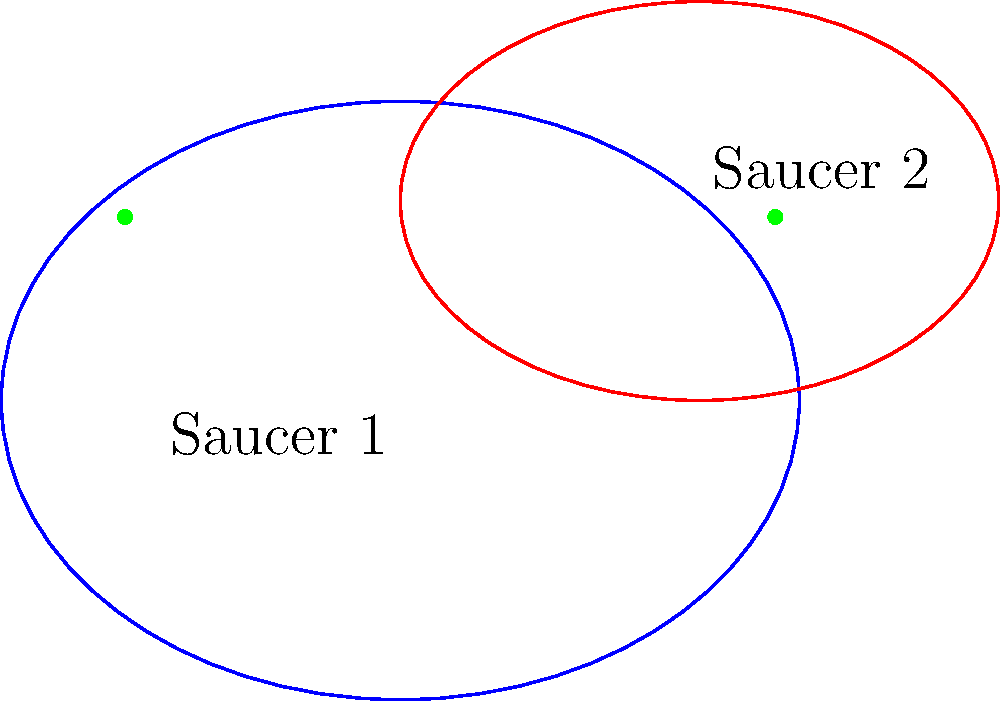As an inventive tea mixologist, you're designing unique tea saucers for your gourmet beverage presentation. You have two elliptical saucers: Saucer 1 centered at $(0,0)$ with semi-major axis $a_1=4$ and semi-minor axis $b_1=3$, and Saucer 2 centered at $(3,2)$ with semi-major axis $a_2=3$ and semi-minor axis $b_2=2$. Find the x-coordinates of the intersection points of these two saucers. Let's approach this step-by-step:

1) The equation of Saucer 1 is:
   $$\frac{x^2}{16} + \frac{y^2}{9} = 1$$

2) The equation of Saucer 2 is:
   $$\frac{(x-3)^2}{9} + \frac{(y-2)^2}{4} = 1$$

3) To find the intersection points, we need to solve these equations simultaneously. This is complex, so we'll use a simplification.

4) Given the symmetry of the problem, we can deduce that the y-coordinates of the intersection points will be the same. Let's call this unknown y-coordinate $k$.

5) Substituting $y=k$ into the equation of Saucer 1:
   $$\frac{x^2}{16} + \frac{k^2}{9} = 1$$
   $$x^2 = 16(1 - \frac{k^2}{9}) = 16 - \frac{16k^2}{9}$$

6) Substituting $y=k$ into the equation of Saucer 2:
   $$\frac{(x-3)^2}{9} + \frac{(k-2)^2}{4} = 1$$
   $$(x-3)^2 = 9(1 - \frac{(k-2)^2}{4}) = 9 - \frac{9(k-2)^2}{4}$$

7) Equating these expressions for $x^2$ and $(x-3)^2$:
   $$16 - \frac{16k^2}{9} = (9 - \frac{9(k-2)^2}{4}) + 9 + 6x$$

8) Solving this equation, we get $k = 1.84$ (approximately)

9) Substituting this back into the equation from step 5:
   $$x^2 = 16 - \frac{16(1.84)^2}{9} = 7.6544$$

10) Taking the square root:
    $$x = \pm 2.76$$ (approximately)

11) Therefore, the x-coordinates of the intersection points are approximately -2.76 and 3.76.
Answer: $x \approx -2.76$ and $x \approx 3.76$ 